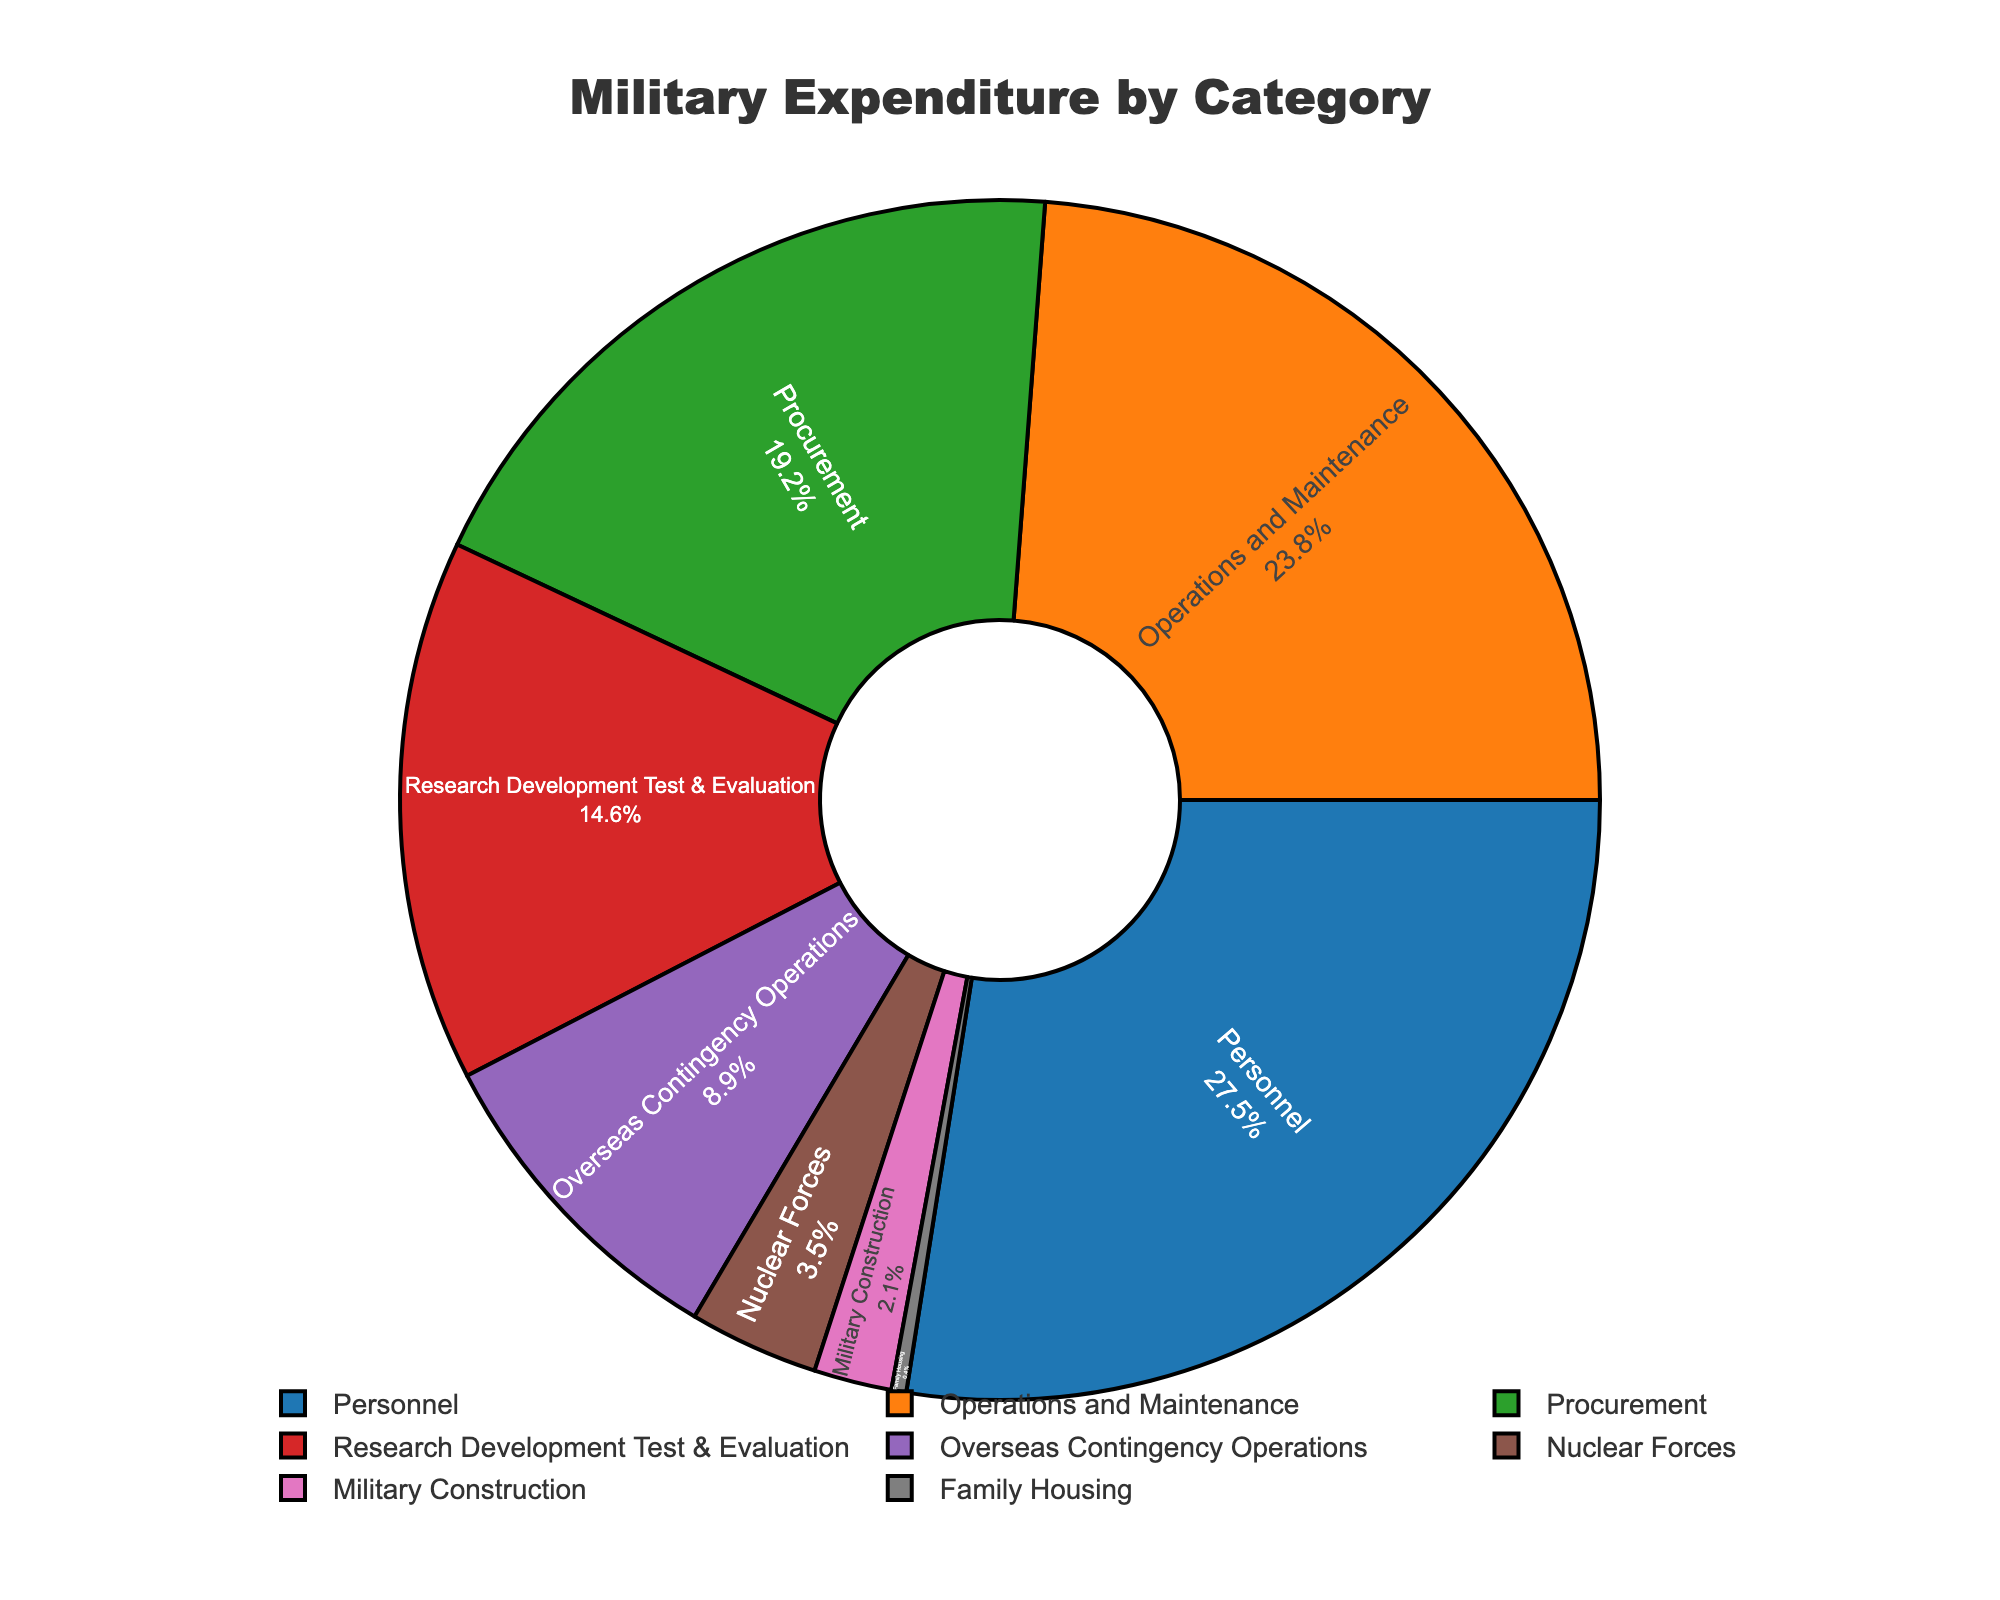what percentage of the military expenditure is allocated to Personnel and Operations and Maintenance combined? To find the combined percentage of Personnel and Operations and Maintenance, you need to add the percentages of both categories together. Personnel is 27.5%, and Operations and Maintenance is 23.8%. So, the combined percentage is 27.5% + 23.8% = 51.3%
Answer: 51.3% which category has the smallest share of the military expenditure? To find the category with the smallest share, look at the percentages for each category and identify the lowest value. Family Housing has the smallest share at 0.4%.
Answer: Family Housing how much greater is the percentage of Procurement compared to Military Construction? To determine how much greater the percentage of Procurement is compared to Military Construction, subtract the percentage of Military Construction from the percentage of Procurement. Procurement is 19.2%, while Military Construction is 2.1%. Thus, 19.2% - 2.1% = 17.1%
Answer: 17.1% which categories combined represent more than 50% of the military expenditure? First, identify the highest percentages until the cumulative sum exceeds 50%. Personnel (27.5%), Operations and Maintenance (23.8%), and Procurement (19.2%) are the top three. Adding these gives 27.5% + 23.8% + 19.2% = 70.5%, which is more than 50%.
Answer: Personnel, Operations and Maintenance, Procurement what is the difference in expenditure percentage between Research Development Test & Evaluation and Nuclear Forces? To find the difference in expenditure percentage between Research Development Test & Evaluation and Nuclear Forces, subtract the percentage of Nuclear Forces from Research Development Test & Evaluation. Research Development Test & Evaluation is 14.6%, while Nuclear Forces is 3.5%. Thus, 14.6% - 3.5% = 11.1%.
Answer: 11.1% what percentage of military expenditure goes towards Overseas Contingency Operations? Look for the percentage value attributed to Overseas Contingency Operations in the data. Overseas Contingency Operations is 8.9%.
Answer: 8.9% how do the proportions of Personnel and Research Development Test & Evaluation compare visually in the pie chart? Visually, you compare the slices in the pie chart corresponding to Personnel and Research Development Test & Evaluation. Personnel has a larger slice (27.5%) compared to Research Development Test & Evaluation (14.6%).
Answer: Personnel's slice is larger than Research Development Test & Evaluation's if the sum of Military Construction and Family Housing is combined, which existing category does it closely match in percentage? Add the percentages of Military Construction and Family Housing together. Military Construction is 2.1%, and Family Housing is 0.4%. Thus, 2.1% + 0.4% = 2.5%. Compare this sum to the existing categories. The closest match is Nuclear Forces at 3.5%.
Answer: Closely matches Nuclear Forces 